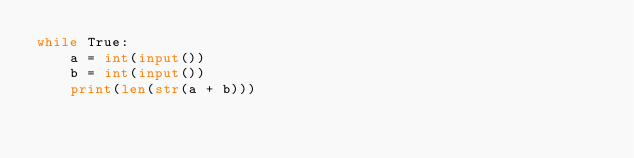Convert code to text. <code><loc_0><loc_0><loc_500><loc_500><_Python_>while True:
    a = int(input())
    b = int(input())
    print(len(str(a + b)))
</code> 